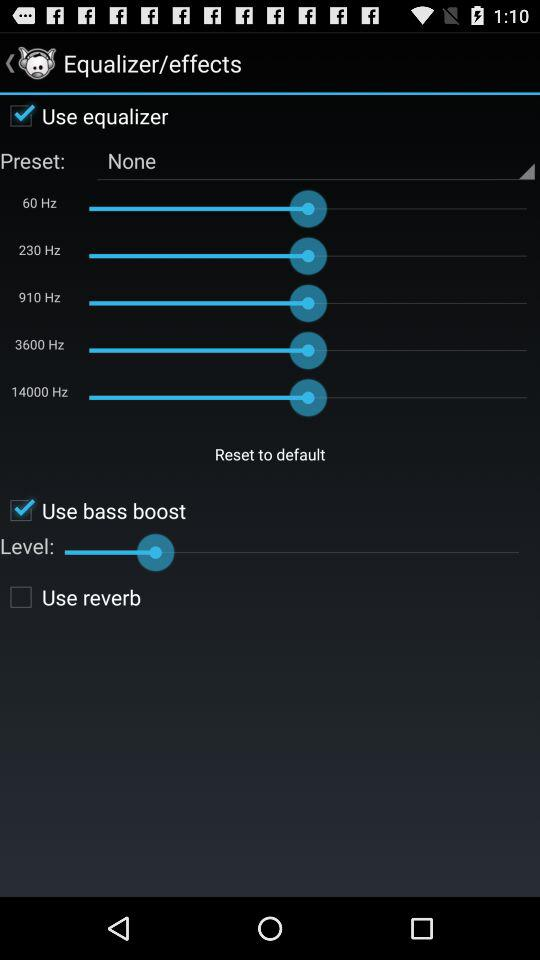What is the selected preset? The selected preset is "None". 